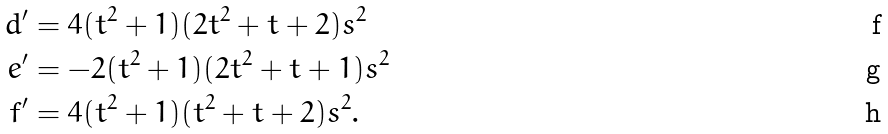<formula> <loc_0><loc_0><loc_500><loc_500>d ^ { \prime } & = 4 ( t ^ { 2 } + 1 ) ( 2 t ^ { 2 } + t + 2 ) s ^ { 2 } \\ e ^ { \prime } & = - 2 ( t ^ { 2 } + 1 ) ( 2 t ^ { 2 } + t + 1 ) s ^ { 2 } \\ f ^ { \prime } & = 4 ( t ^ { 2 } + 1 ) ( t ^ { 2 } + t + 2 ) s ^ { 2 } .</formula> 